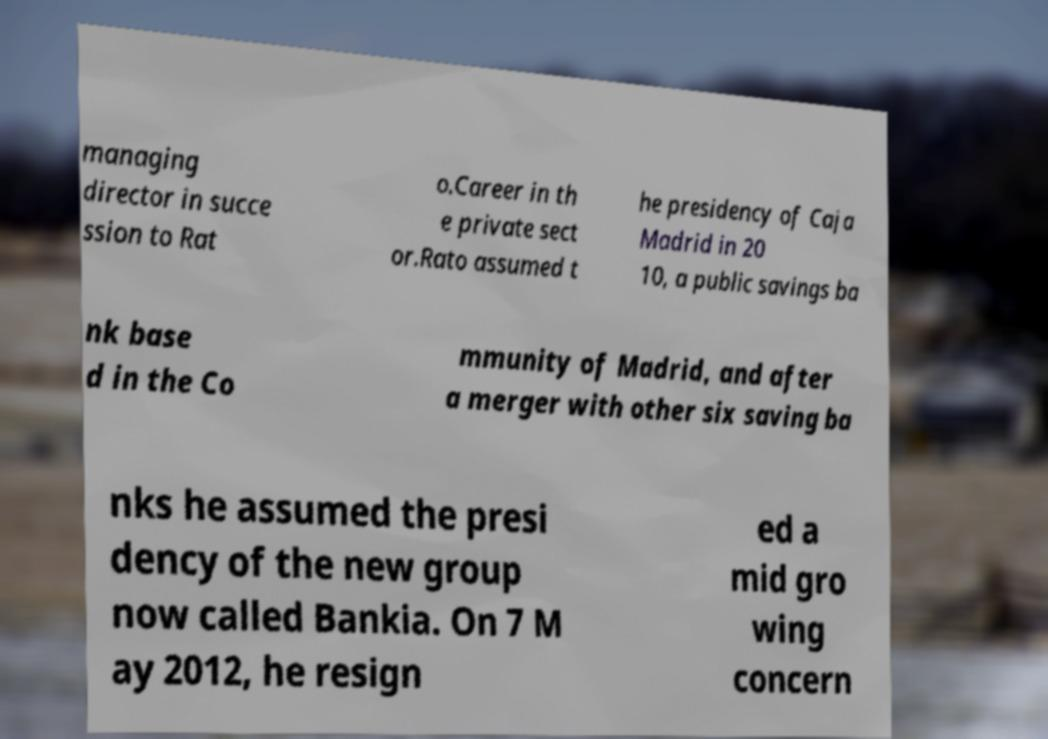What messages or text are displayed in this image? I need them in a readable, typed format. managing director in succe ssion to Rat o.Career in th e private sect or.Rato assumed t he presidency of Caja Madrid in 20 10, a public savings ba nk base d in the Co mmunity of Madrid, and after a merger with other six saving ba nks he assumed the presi dency of the new group now called Bankia. On 7 M ay 2012, he resign ed a mid gro wing concern 